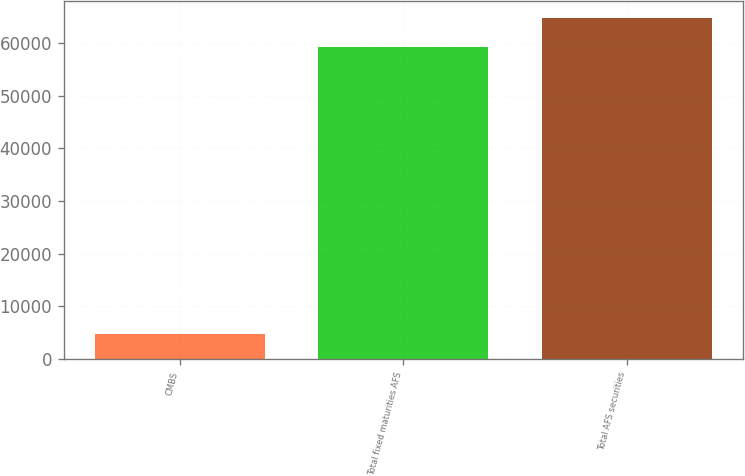<chart> <loc_0><loc_0><loc_500><loc_500><bar_chart><fcel>CMBS<fcel>Total fixed maturities AFS<fcel>Total AFS securities<nl><fcel>4717<fcel>59196<fcel>64727.8<nl></chart> 